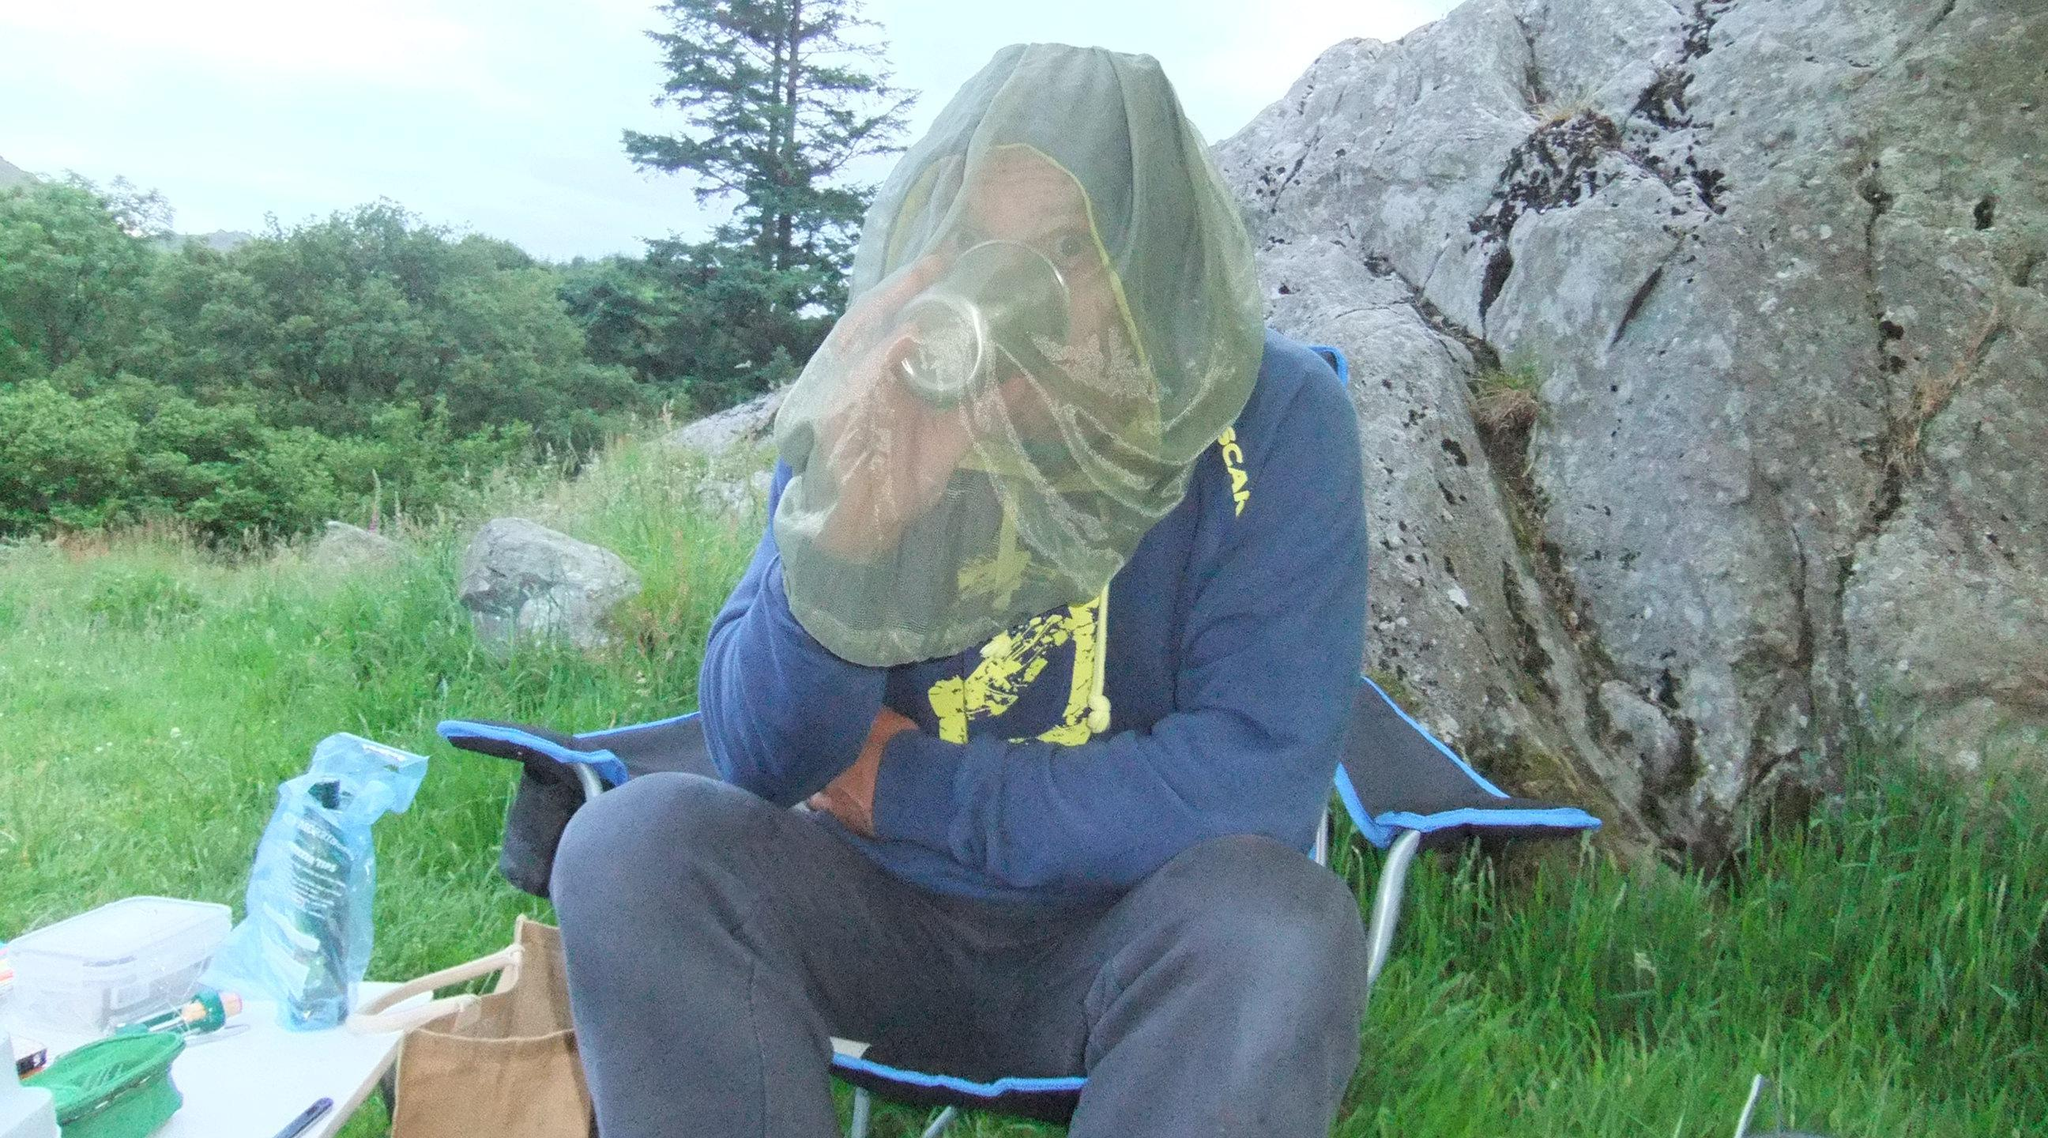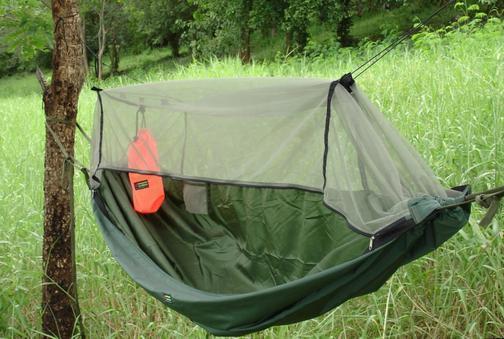The first image is the image on the left, the second image is the image on the right. For the images displayed, is the sentence "An image shows a hanging hammock that does not contain a person." factually correct? Answer yes or no. Yes. The first image is the image on the left, the second image is the image on the right. Examine the images to the left and right. Is the description "A blue hammock hangs from a tree in one of the images." accurate? Answer yes or no. No. 